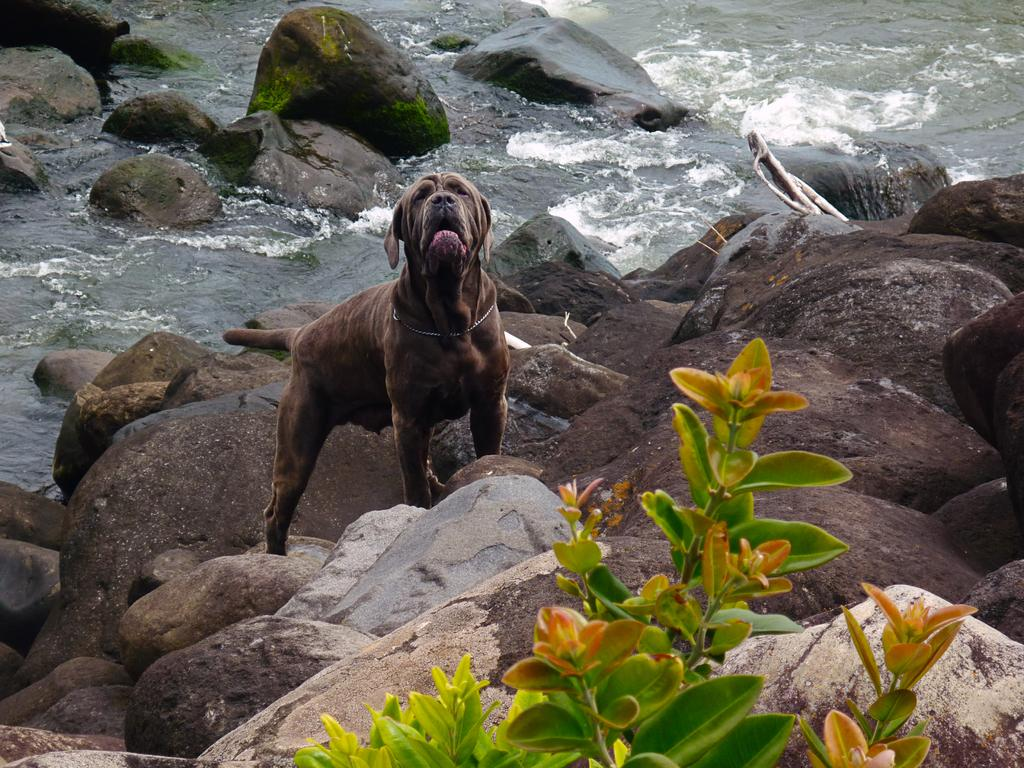What type of animal is in the image? There is a brown dog in the image. What can be seen at the bottom of the image? There are rocks at the bottom of the image. What is located near the rocks? There is a plant near the rocks. What is happening in the background of the image? Water is flowing in the background of the image. What is the title of the book the dog is reading in the image? There is no book or reading activity depicted in the image; the dog is simply present in the scene. 